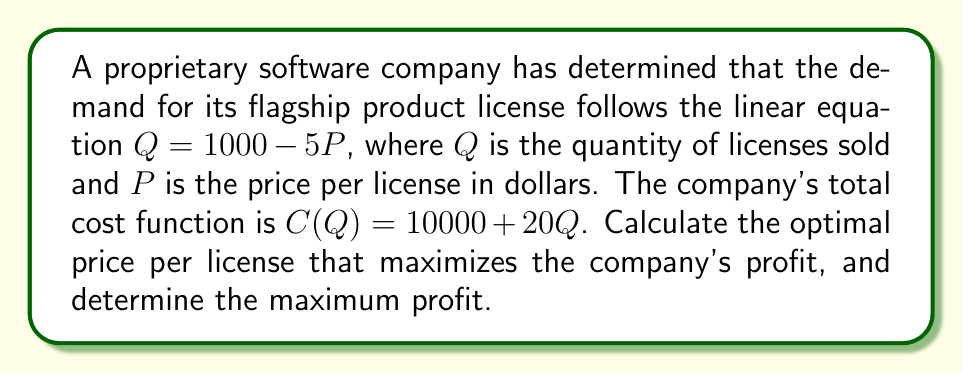Solve this math problem. 1. The revenue function is given by:
   $R(P) = P \cdot Q = P \cdot (1000 - 5P) = 1000P - 5P^2$

2. The profit function is revenue minus cost:
   $\Pi(P) = R(P) - C(Q)$
   $\Pi(P) = (1000P - 5P^2) - [10000 + 20(1000 - 5P)]$
   $\Pi(P) = 1000P - 5P^2 - 10000 - 20000 + 100P$
   $\Pi(P) = -5P^2 + 1100P - 30000$

3. To find the maximum profit, we differentiate $\Pi(P)$ with respect to $P$ and set it to zero:
   $\frac{d\Pi}{dP} = -10P + 1100 = 0$

4. Solve for $P$:
   $-10P = -1100$
   $P = 110$

5. Verify this is a maximum by checking the second derivative:
   $\frac{d^2\Pi}{dP^2} = -10 < 0$, confirming a maximum.

6. The optimal price is $110 per license.

7. Calculate the maximum profit by substituting $P = 110$ into the profit function:
   $\Pi(110) = -5(110)^2 + 1100(110) - 30000$
   $\Pi(110) = -60500 + 121000 - 30000 = 30500$

Therefore, the maximum profit is $30,500.
Answer: Optimal price: $110 per license; Maximum profit: $30,500 